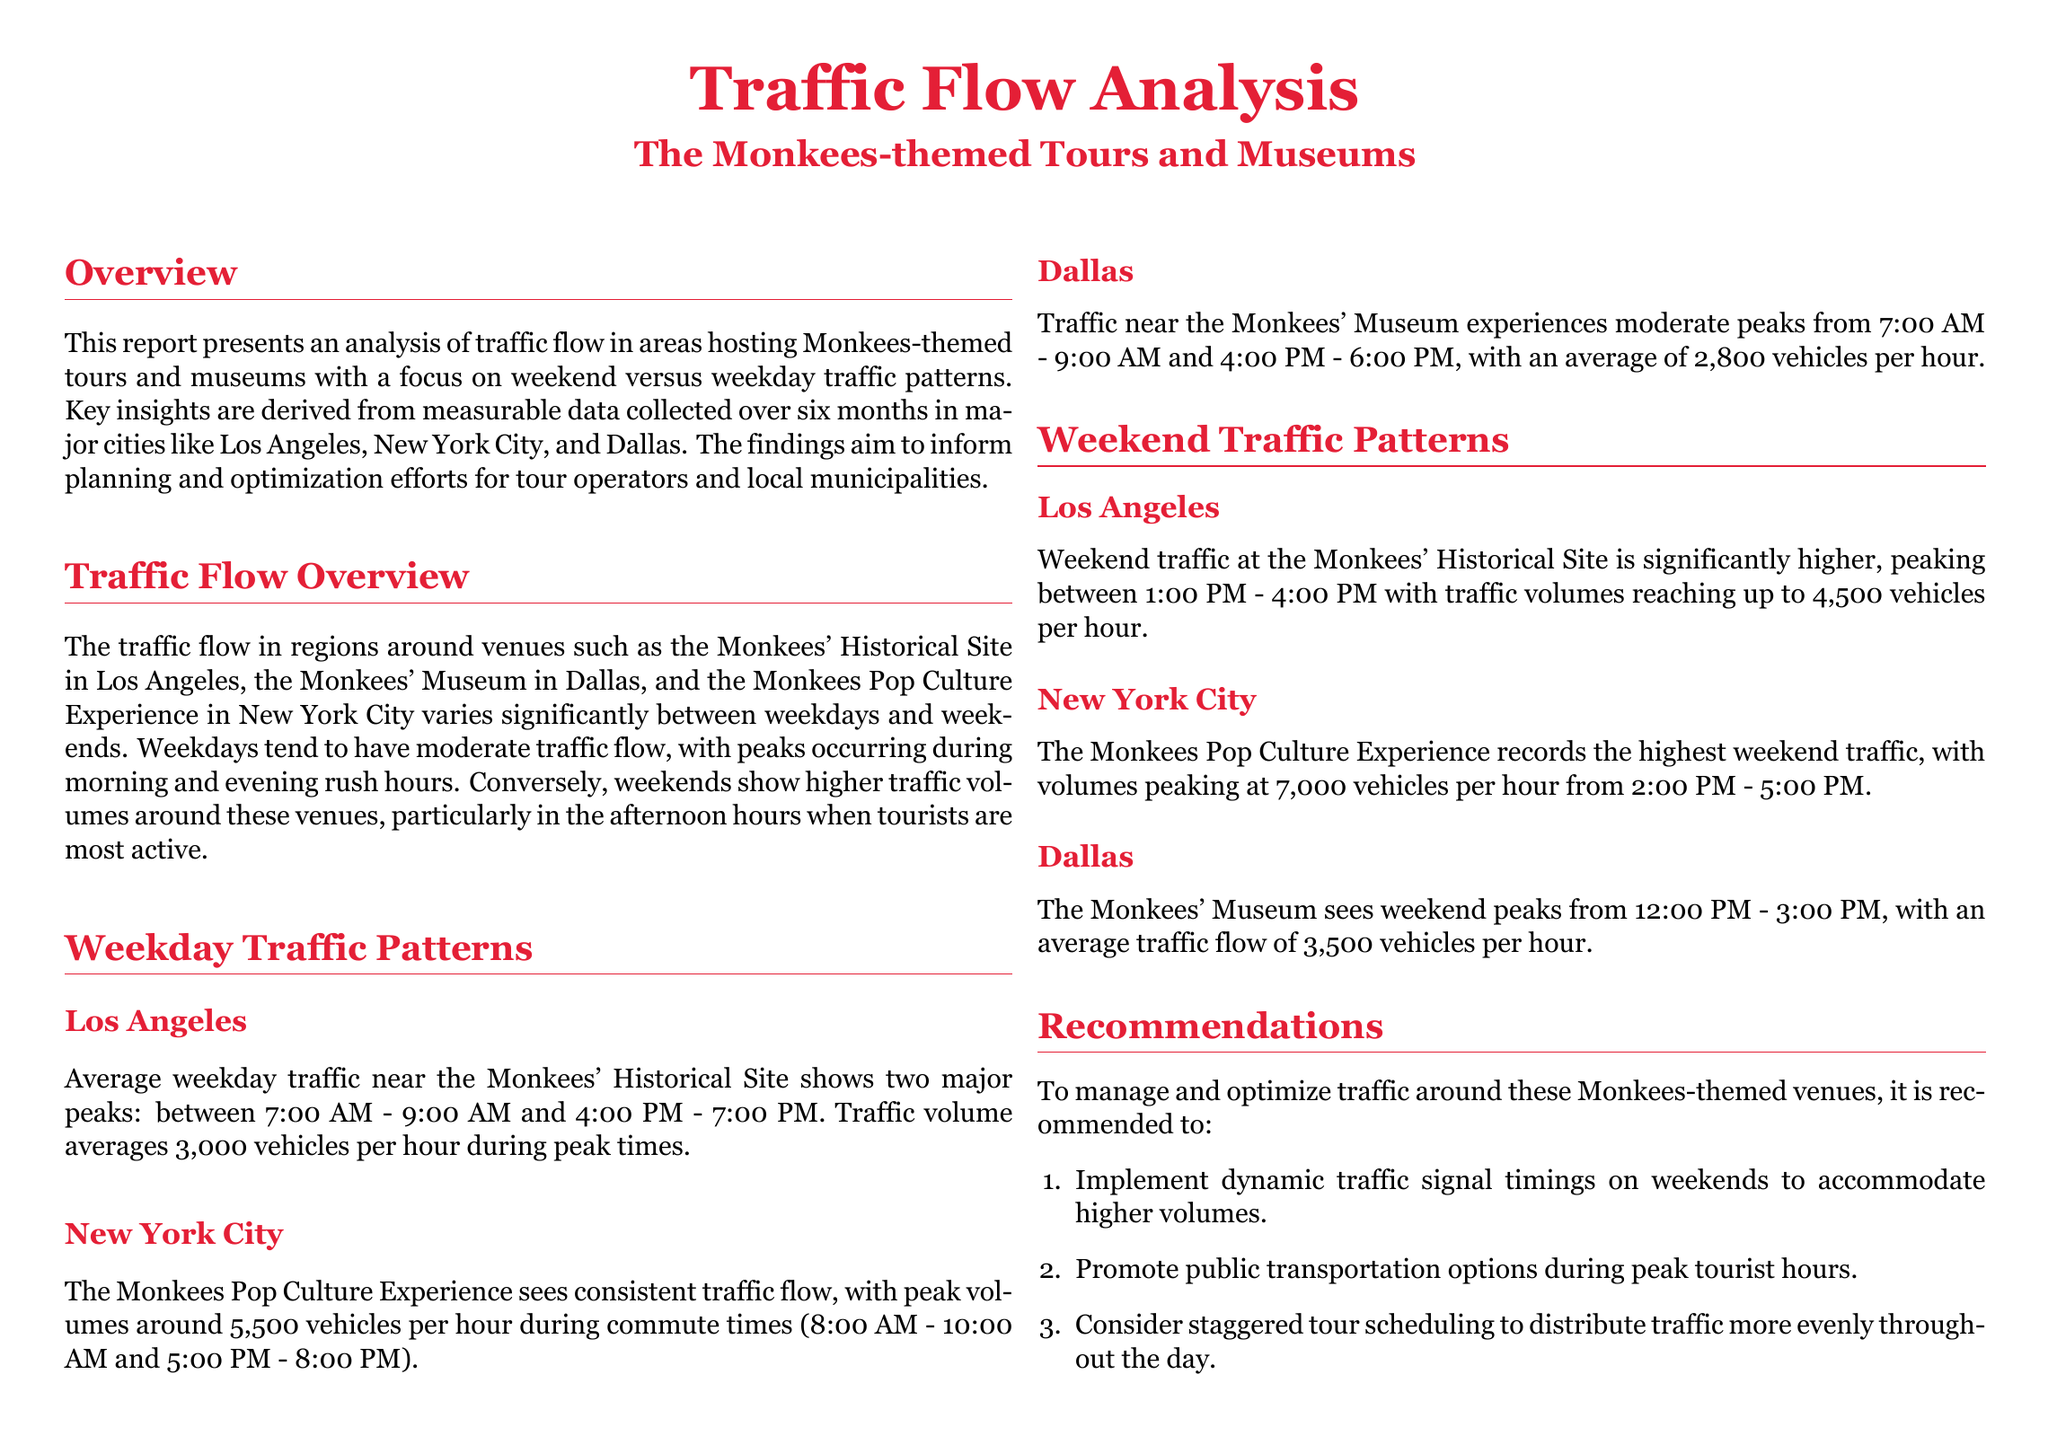what is the average peak traffic in Los Angeles on weekdays? The average peak traffic in Los Angeles on weekdays is stated to be 3,000 vehicles per hour during peak times.
Answer: 3,000 vehicles per hour what time does peak traffic occur in New York City on weekdays? Peak traffic in New York City on weekdays occurs at two specific time periods: 8:00 AM - 10:00 AM and 5:00 PM - 8:00 PM.
Answer: 8:00 AM - 10:00 AM and 5:00 PM - 8:00 PM how many vehicles per hour peak traffic reaches at the Monkees Pop Culture Experience on weekends? The Monkees Pop Culture Experience reaches peak traffic volumes of 7,000 vehicles per hour on weekends.
Answer: 7,000 vehicles per hour what are the recommended actions to manage traffic on weekends? The document recommends implementing dynamic traffic signal timings, promoting public transportation options, and considering staggered tour scheduling.
Answer: Dynamic traffic signal timings what is the average traffic flow during weekend afternoons at the Monkees' Museum in Dallas? The average traffic flow during weekend afternoons at the Monkees' Museum in Dallas is noted to be 3,500 vehicles per hour.
Answer: 3,500 vehicles per hour what is the peak time for weekend traffic at the Monkees' Historical Site in Los Angeles? The peak time for weekend traffic at the Monkees' Historical Site in Los Angeles is between 1:00 PM - 4:00 PM.
Answer: 1:00 PM - 4:00 PM how do weekend traffic levels compare to weekday levels around Monkees-themed venues? Weekend traffic levels are significantly higher than weekday levels around Monkees-themed venues, particularly in the afternoon.
Answer: significantly higher what is the analysis timeframe covered in the report? The report covers a timeframe of six months for the traffic flow analysis.
Answer: six months 